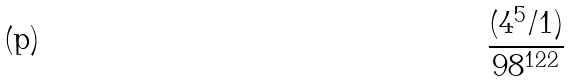Convert formula to latex. <formula><loc_0><loc_0><loc_500><loc_500>\frac { ( 4 ^ { 5 } / 1 ) } { 9 8 ^ { 1 2 2 } }</formula> 